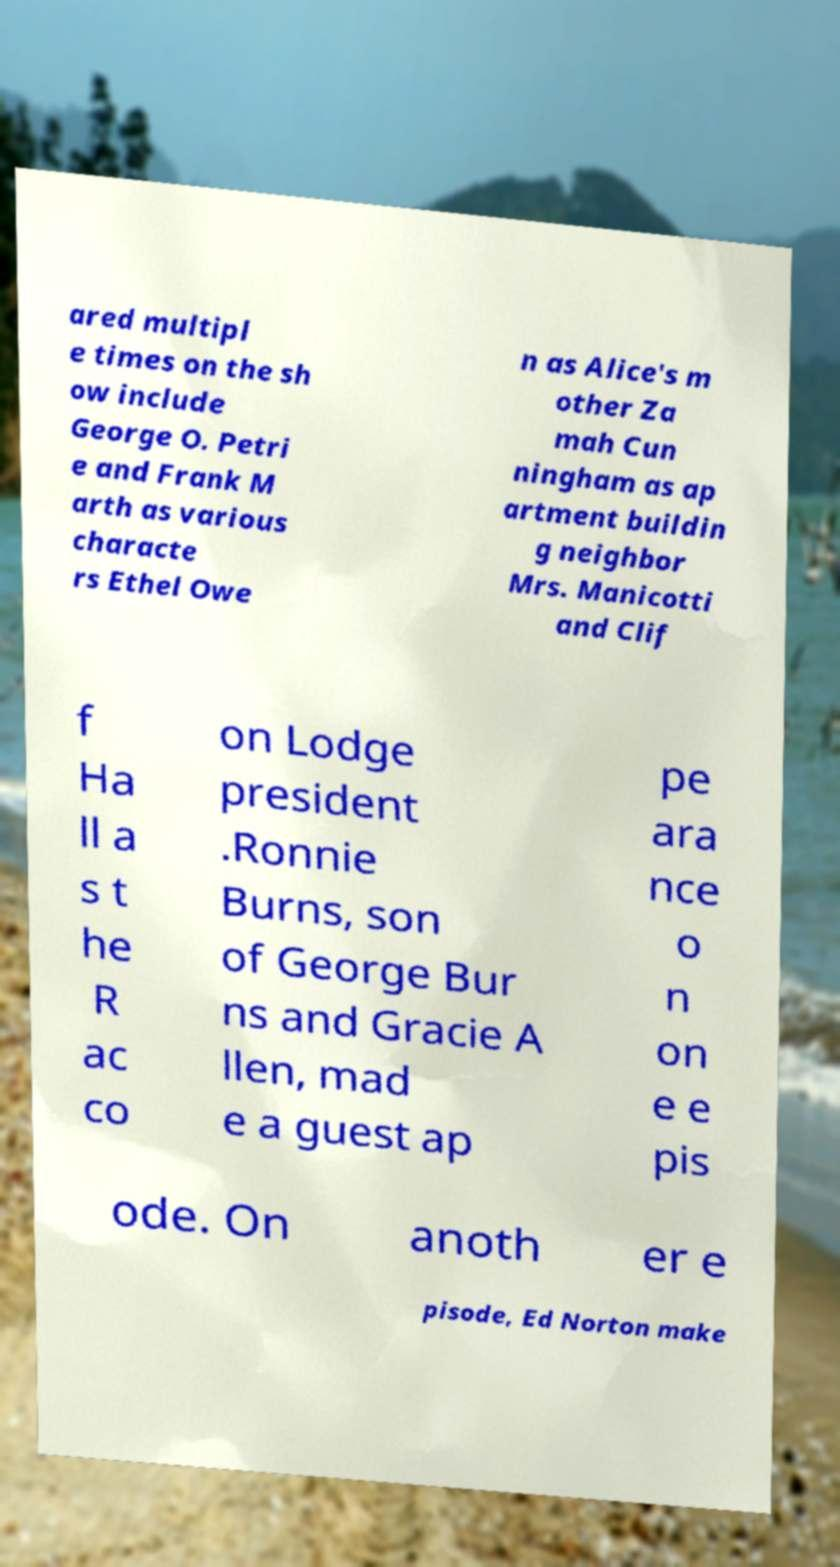There's text embedded in this image that I need extracted. Can you transcribe it verbatim? ared multipl e times on the sh ow include George O. Petri e and Frank M arth as various characte rs Ethel Owe n as Alice's m other Za mah Cun ningham as ap artment buildin g neighbor Mrs. Manicotti and Clif f Ha ll a s t he R ac co on Lodge president .Ronnie Burns, son of George Bur ns and Gracie A llen, mad e a guest ap pe ara nce o n on e e pis ode. On anoth er e pisode, Ed Norton make 